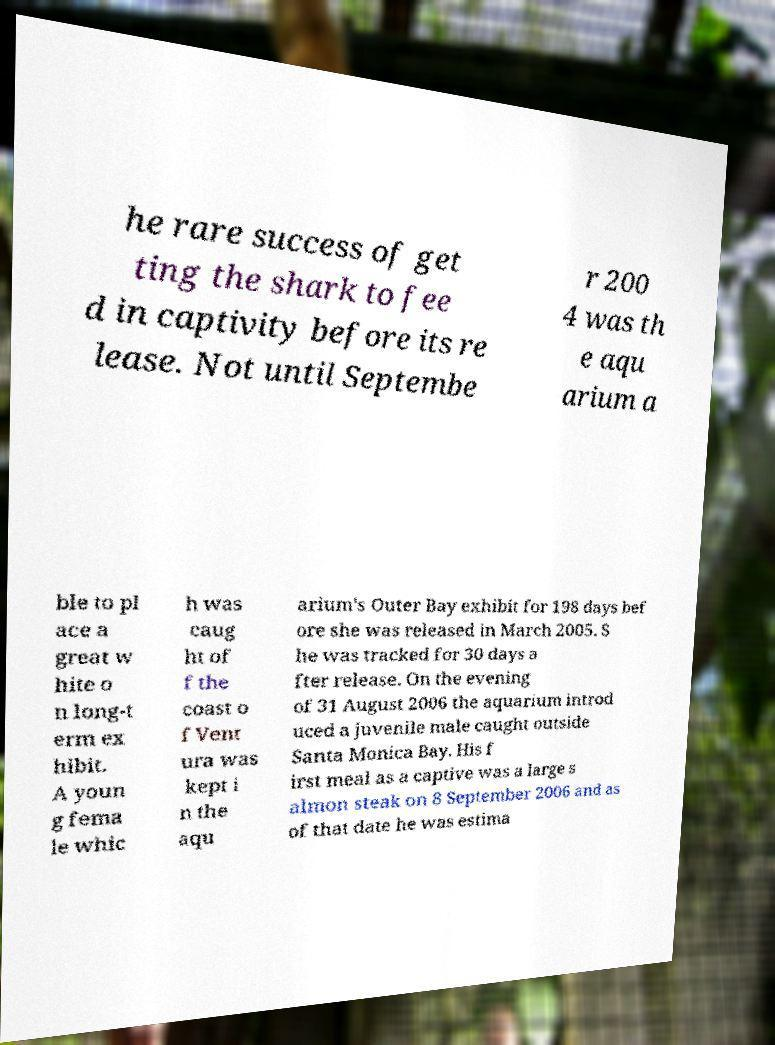Please read and relay the text visible in this image. What does it say? he rare success of get ting the shark to fee d in captivity before its re lease. Not until Septembe r 200 4 was th e aqu arium a ble to pl ace a great w hite o n long-t erm ex hibit. A youn g fema le whic h was caug ht of f the coast o f Vent ura was kept i n the aqu arium's Outer Bay exhibit for 198 days bef ore she was released in March 2005. S he was tracked for 30 days a fter release. On the evening of 31 August 2006 the aquarium introd uced a juvenile male caught outside Santa Monica Bay. His f irst meal as a captive was a large s almon steak on 8 September 2006 and as of that date he was estima 